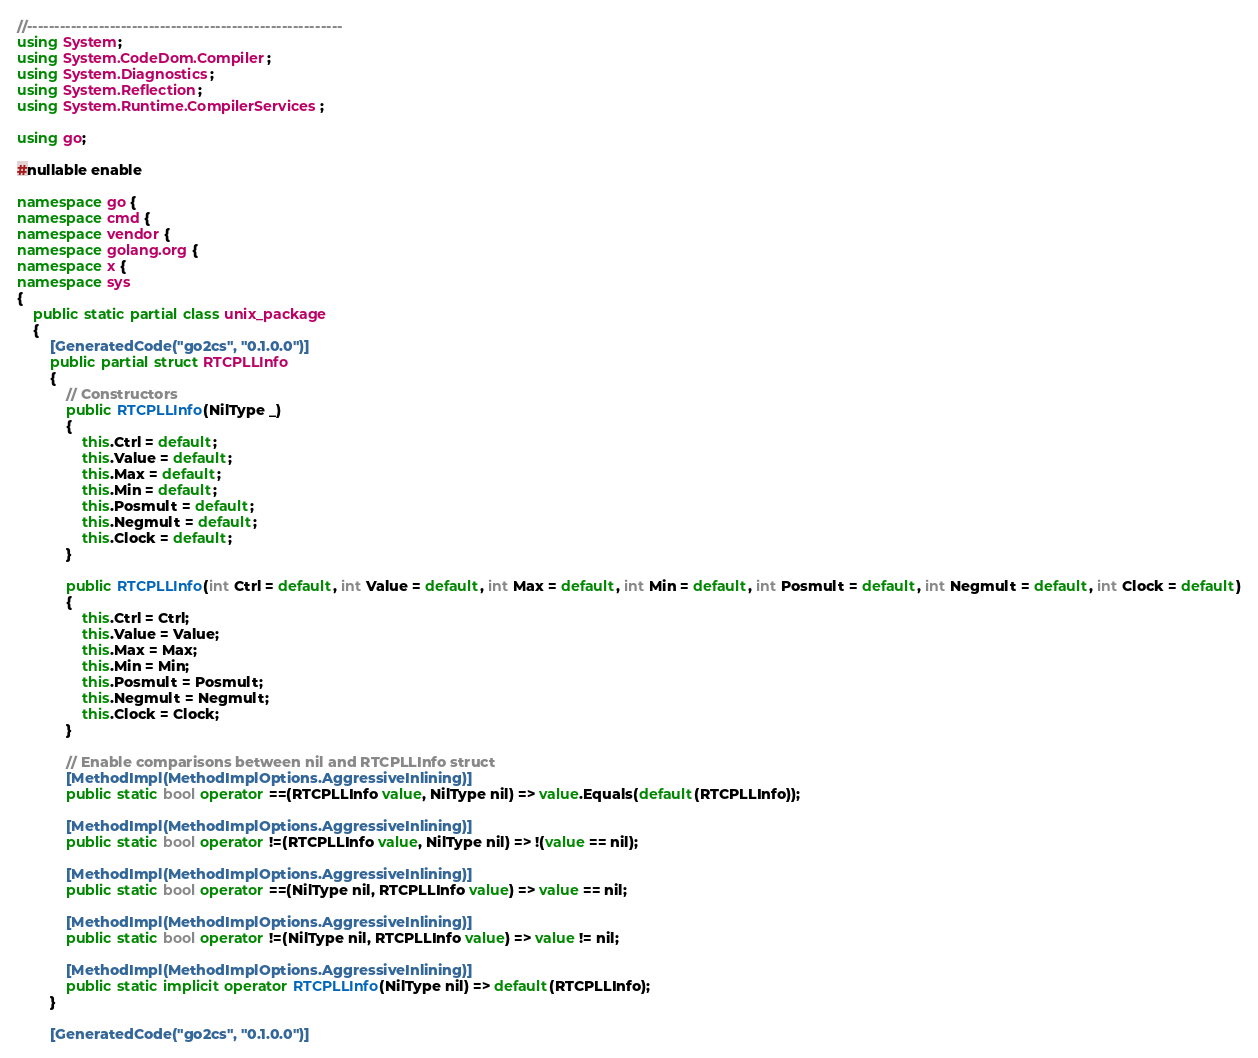<code> <loc_0><loc_0><loc_500><loc_500><_C#_>//---------------------------------------------------------
using System;
using System.CodeDom.Compiler;
using System.Diagnostics;
using System.Reflection;
using System.Runtime.CompilerServices;

using go;

#nullable enable

namespace go {
namespace cmd {
namespace vendor {
namespace golang.org {
namespace x {
namespace sys
{
    public static partial class unix_package
    {
        [GeneratedCode("go2cs", "0.1.0.0")]
        public partial struct RTCPLLInfo
        {
            // Constructors
            public RTCPLLInfo(NilType _)
            {
                this.Ctrl = default;
                this.Value = default;
                this.Max = default;
                this.Min = default;
                this.Posmult = default;
                this.Negmult = default;
                this.Clock = default;
            }

            public RTCPLLInfo(int Ctrl = default, int Value = default, int Max = default, int Min = default, int Posmult = default, int Negmult = default, int Clock = default)
            {
                this.Ctrl = Ctrl;
                this.Value = Value;
                this.Max = Max;
                this.Min = Min;
                this.Posmult = Posmult;
                this.Negmult = Negmult;
                this.Clock = Clock;
            }

            // Enable comparisons between nil and RTCPLLInfo struct
            [MethodImpl(MethodImplOptions.AggressiveInlining)]
            public static bool operator ==(RTCPLLInfo value, NilType nil) => value.Equals(default(RTCPLLInfo));

            [MethodImpl(MethodImplOptions.AggressiveInlining)]
            public static bool operator !=(RTCPLLInfo value, NilType nil) => !(value == nil);

            [MethodImpl(MethodImplOptions.AggressiveInlining)]
            public static bool operator ==(NilType nil, RTCPLLInfo value) => value == nil;

            [MethodImpl(MethodImplOptions.AggressiveInlining)]
            public static bool operator !=(NilType nil, RTCPLLInfo value) => value != nil;

            [MethodImpl(MethodImplOptions.AggressiveInlining)]
            public static implicit operator RTCPLLInfo(NilType nil) => default(RTCPLLInfo);
        }

        [GeneratedCode("go2cs", "0.1.0.0")]</code> 